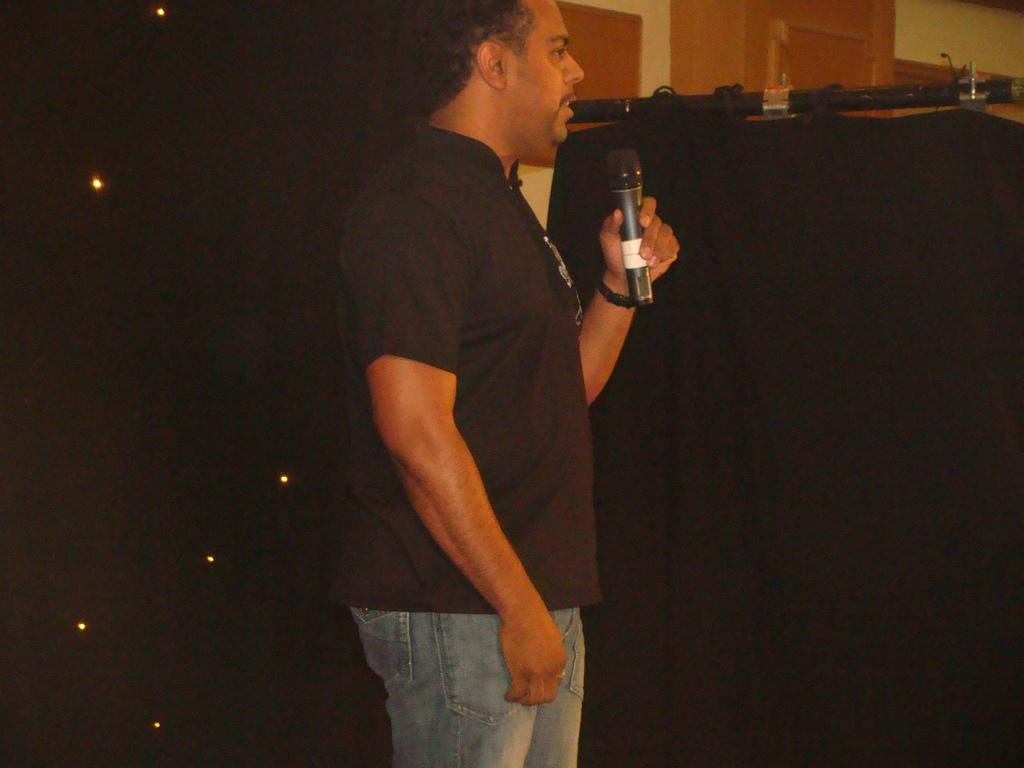Who is the person in the image? There is a man in the image. What is the man holding in the image? The man is holding a microphone. What is the man wearing in the image? The man is wearing a black t-shirt. What can be seen in the background of the image? There are lights visible in the image. What type of wood is being used to support the microphone in the image? There is no wood present in the image, and the microphone is not being supported by any visible structure. 